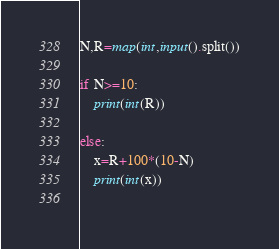<code> <loc_0><loc_0><loc_500><loc_500><_Python_>N,R=map(int,input().split())

if N>=10:
    print(int(R))

else:
    x=R+100*(10-N)
    print(int(x))
    </code> 